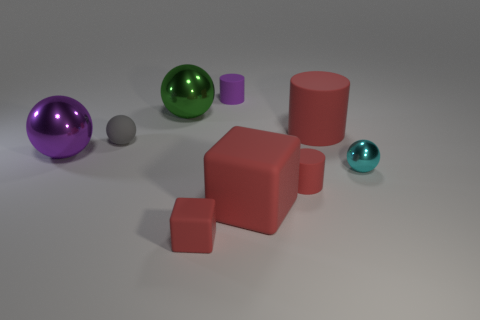Add 1 small metallic things. How many objects exist? 10 Subtract all cylinders. How many objects are left? 6 Add 8 cyan metal spheres. How many cyan metal spheres are left? 9 Add 3 big red objects. How many big red objects exist? 5 Subtract 1 gray spheres. How many objects are left? 8 Subtract all large gray rubber cubes. Subtract all small cyan shiny spheres. How many objects are left? 8 